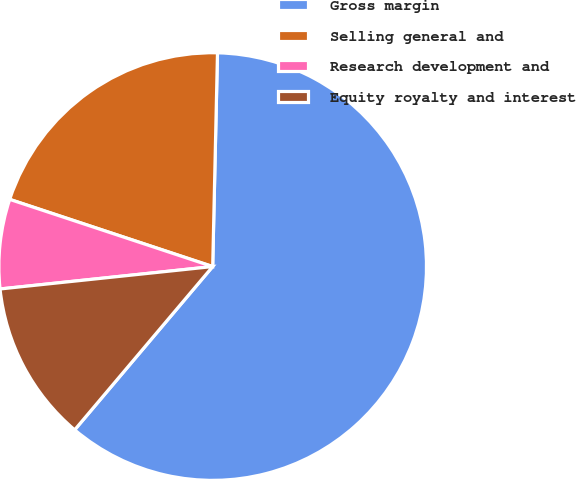<chart> <loc_0><loc_0><loc_500><loc_500><pie_chart><fcel>Gross margin<fcel>Selling general and<fcel>Research development and<fcel>Equity royalty and interest<nl><fcel>60.81%<fcel>20.27%<fcel>6.76%<fcel>12.16%<nl></chart> 